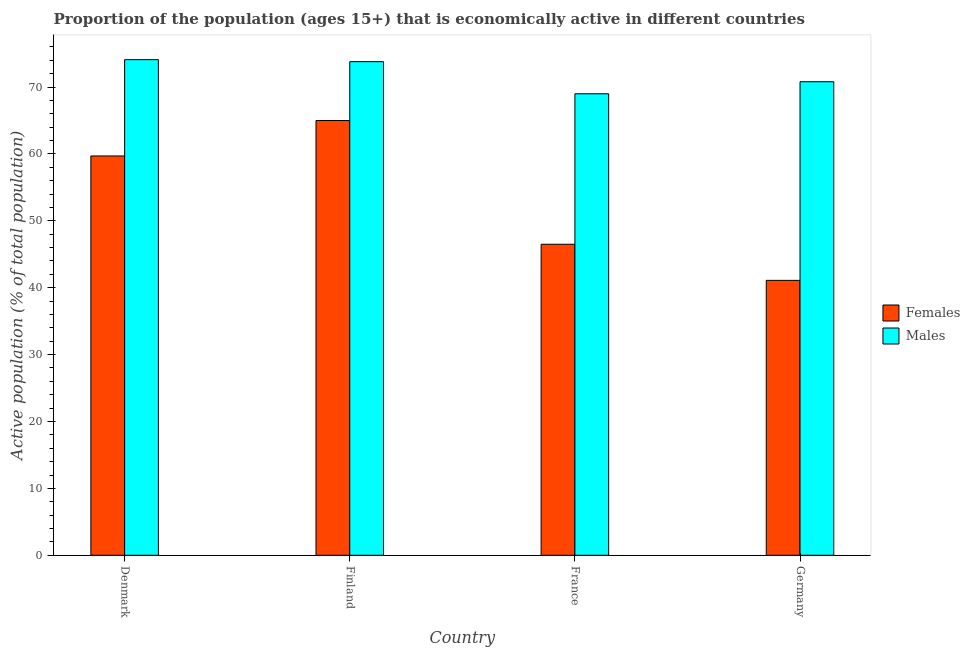Are the number of bars on each tick of the X-axis equal?
Make the answer very short. Yes. How many bars are there on the 4th tick from the right?
Keep it short and to the point. 2. What is the percentage of economically active male population in Denmark?
Your response must be concise. 74.1. Across all countries, what is the maximum percentage of economically active male population?
Your response must be concise. 74.1. Across all countries, what is the minimum percentage of economically active male population?
Provide a short and direct response. 69. What is the total percentage of economically active female population in the graph?
Keep it short and to the point. 212.3. What is the difference between the percentage of economically active female population in Finland and that in France?
Provide a succinct answer. 18.5. What is the difference between the percentage of economically active male population in Denmark and the percentage of economically active female population in France?
Give a very brief answer. 27.6. What is the average percentage of economically active male population per country?
Your answer should be very brief. 71.93. What is the difference between the percentage of economically active female population and percentage of economically active male population in Germany?
Keep it short and to the point. -29.7. In how many countries, is the percentage of economically active male population greater than 12 %?
Your response must be concise. 4. What is the ratio of the percentage of economically active male population in Finland to that in Germany?
Give a very brief answer. 1.04. Is the difference between the percentage of economically active female population in Finland and France greater than the difference between the percentage of economically active male population in Finland and France?
Your answer should be compact. Yes. What is the difference between the highest and the second highest percentage of economically active female population?
Your answer should be compact. 5.3. What is the difference between the highest and the lowest percentage of economically active male population?
Ensure brevity in your answer.  5.1. What does the 2nd bar from the left in Denmark represents?
Provide a short and direct response. Males. What does the 1st bar from the right in Germany represents?
Keep it short and to the point. Males. How many bars are there?
Give a very brief answer. 8. How many countries are there in the graph?
Provide a short and direct response. 4. Are the values on the major ticks of Y-axis written in scientific E-notation?
Give a very brief answer. No. Does the graph contain grids?
Offer a very short reply. No. Where does the legend appear in the graph?
Offer a terse response. Center right. How many legend labels are there?
Your answer should be very brief. 2. How are the legend labels stacked?
Provide a short and direct response. Vertical. What is the title of the graph?
Offer a very short reply. Proportion of the population (ages 15+) that is economically active in different countries. Does "Secondary school" appear as one of the legend labels in the graph?
Provide a succinct answer. No. What is the label or title of the Y-axis?
Keep it short and to the point. Active population (% of total population). What is the Active population (% of total population) of Females in Denmark?
Offer a very short reply. 59.7. What is the Active population (% of total population) of Males in Denmark?
Make the answer very short. 74.1. What is the Active population (% of total population) in Females in Finland?
Provide a short and direct response. 65. What is the Active population (% of total population) in Males in Finland?
Provide a short and direct response. 73.8. What is the Active population (% of total population) in Females in France?
Ensure brevity in your answer.  46.5. What is the Active population (% of total population) of Females in Germany?
Provide a short and direct response. 41.1. What is the Active population (% of total population) in Males in Germany?
Ensure brevity in your answer.  70.8. Across all countries, what is the maximum Active population (% of total population) of Males?
Ensure brevity in your answer.  74.1. Across all countries, what is the minimum Active population (% of total population) in Females?
Offer a very short reply. 41.1. What is the total Active population (% of total population) of Females in the graph?
Your response must be concise. 212.3. What is the total Active population (% of total population) in Males in the graph?
Ensure brevity in your answer.  287.7. What is the difference between the Active population (% of total population) of Males in Denmark and that in France?
Offer a very short reply. 5.1. What is the difference between the Active population (% of total population) of Females in Denmark and that in Germany?
Your answer should be very brief. 18.6. What is the difference between the Active population (% of total population) of Males in Denmark and that in Germany?
Ensure brevity in your answer.  3.3. What is the difference between the Active population (% of total population) in Females in Finland and that in France?
Give a very brief answer. 18.5. What is the difference between the Active population (% of total population) in Males in Finland and that in France?
Offer a terse response. 4.8. What is the difference between the Active population (% of total population) of Females in Finland and that in Germany?
Offer a very short reply. 23.9. What is the difference between the Active population (% of total population) of Males in Finland and that in Germany?
Offer a very short reply. 3. What is the difference between the Active population (% of total population) of Females in France and that in Germany?
Provide a succinct answer. 5.4. What is the difference between the Active population (% of total population) of Females in Denmark and the Active population (% of total population) of Males in Finland?
Your response must be concise. -14.1. What is the difference between the Active population (% of total population) of Females in Denmark and the Active population (% of total population) of Males in Germany?
Your answer should be very brief. -11.1. What is the difference between the Active population (% of total population) in Females in France and the Active population (% of total population) in Males in Germany?
Ensure brevity in your answer.  -24.3. What is the average Active population (% of total population) in Females per country?
Your answer should be compact. 53.08. What is the average Active population (% of total population) of Males per country?
Your response must be concise. 71.92. What is the difference between the Active population (% of total population) in Females and Active population (% of total population) in Males in Denmark?
Your response must be concise. -14.4. What is the difference between the Active population (% of total population) of Females and Active population (% of total population) of Males in Finland?
Your answer should be very brief. -8.8. What is the difference between the Active population (% of total population) of Females and Active population (% of total population) of Males in France?
Your answer should be compact. -22.5. What is the difference between the Active population (% of total population) in Females and Active population (% of total population) in Males in Germany?
Make the answer very short. -29.7. What is the ratio of the Active population (% of total population) of Females in Denmark to that in Finland?
Your response must be concise. 0.92. What is the ratio of the Active population (% of total population) in Females in Denmark to that in France?
Ensure brevity in your answer.  1.28. What is the ratio of the Active population (% of total population) in Males in Denmark to that in France?
Your answer should be compact. 1.07. What is the ratio of the Active population (% of total population) of Females in Denmark to that in Germany?
Provide a succinct answer. 1.45. What is the ratio of the Active population (% of total population) in Males in Denmark to that in Germany?
Provide a short and direct response. 1.05. What is the ratio of the Active population (% of total population) of Females in Finland to that in France?
Provide a short and direct response. 1.4. What is the ratio of the Active population (% of total population) in Males in Finland to that in France?
Your answer should be compact. 1.07. What is the ratio of the Active population (% of total population) of Females in Finland to that in Germany?
Keep it short and to the point. 1.58. What is the ratio of the Active population (% of total population) in Males in Finland to that in Germany?
Your answer should be compact. 1.04. What is the ratio of the Active population (% of total population) of Females in France to that in Germany?
Provide a succinct answer. 1.13. What is the ratio of the Active population (% of total population) of Males in France to that in Germany?
Ensure brevity in your answer.  0.97. What is the difference between the highest and the lowest Active population (% of total population) of Females?
Ensure brevity in your answer.  23.9. 